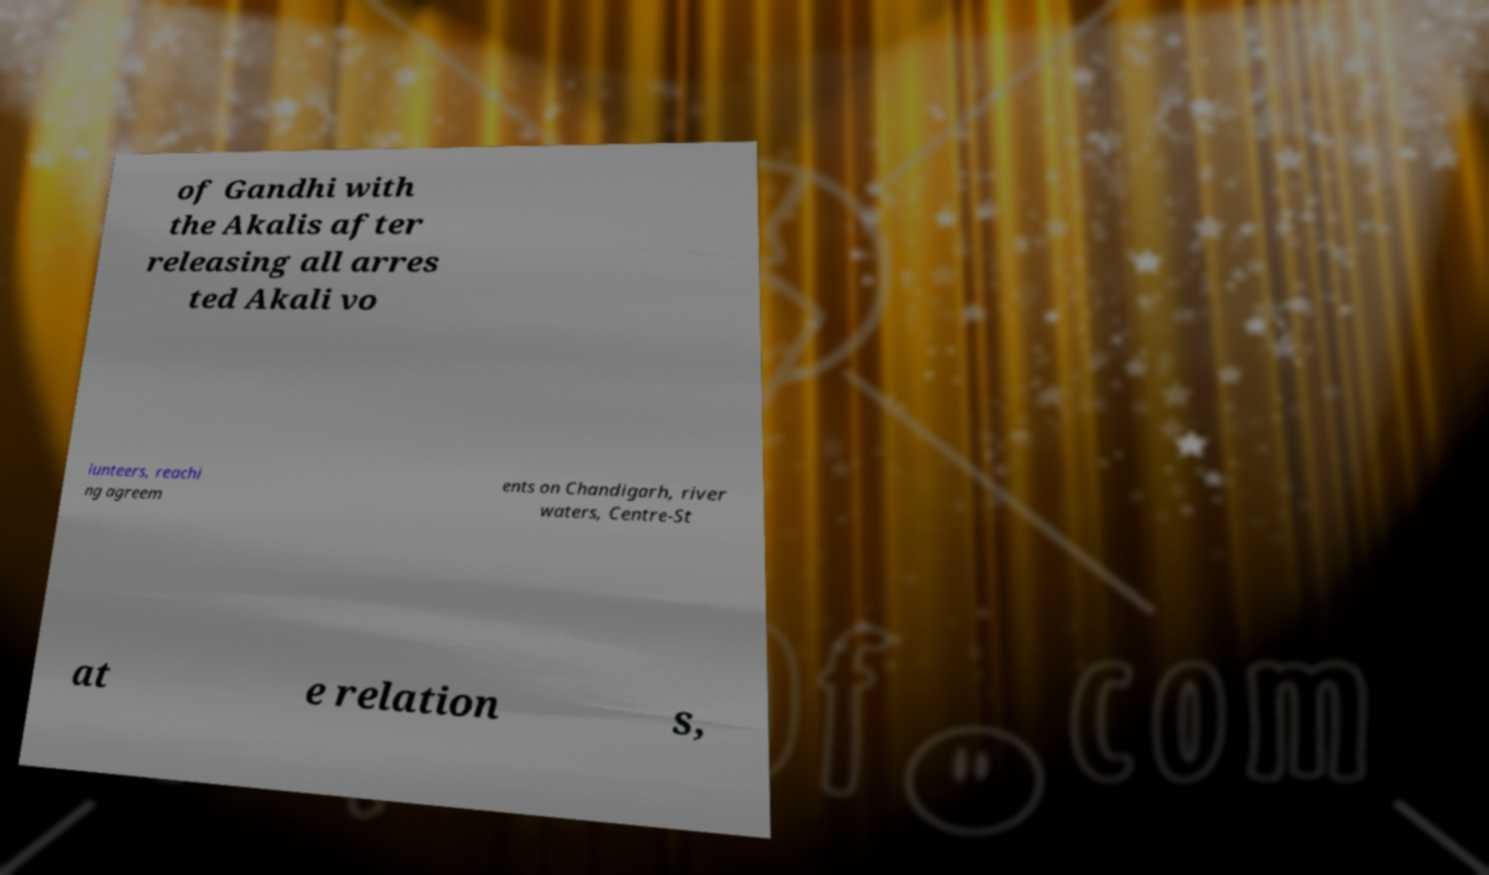Please read and relay the text visible in this image. What does it say? of Gandhi with the Akalis after releasing all arres ted Akali vo lunteers, reachi ng agreem ents on Chandigarh, river waters, Centre-St at e relation s, 